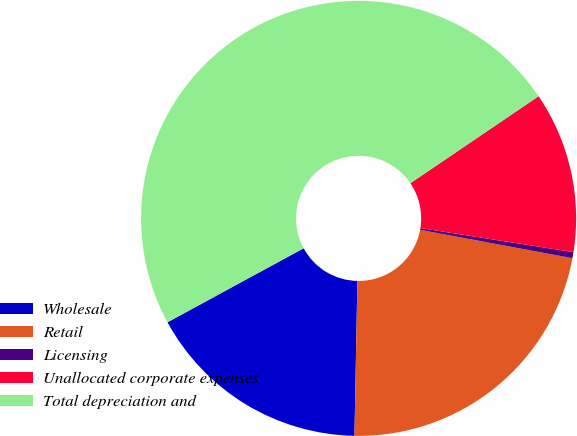Convert chart to OTSL. <chart><loc_0><loc_0><loc_500><loc_500><pie_chart><fcel>Wholesale<fcel>Retail<fcel>Licensing<fcel>Unallocated corporate expenses<fcel>Total depreciation and<nl><fcel>16.77%<fcel>22.37%<fcel>0.45%<fcel>11.97%<fcel>48.43%<nl></chart> 